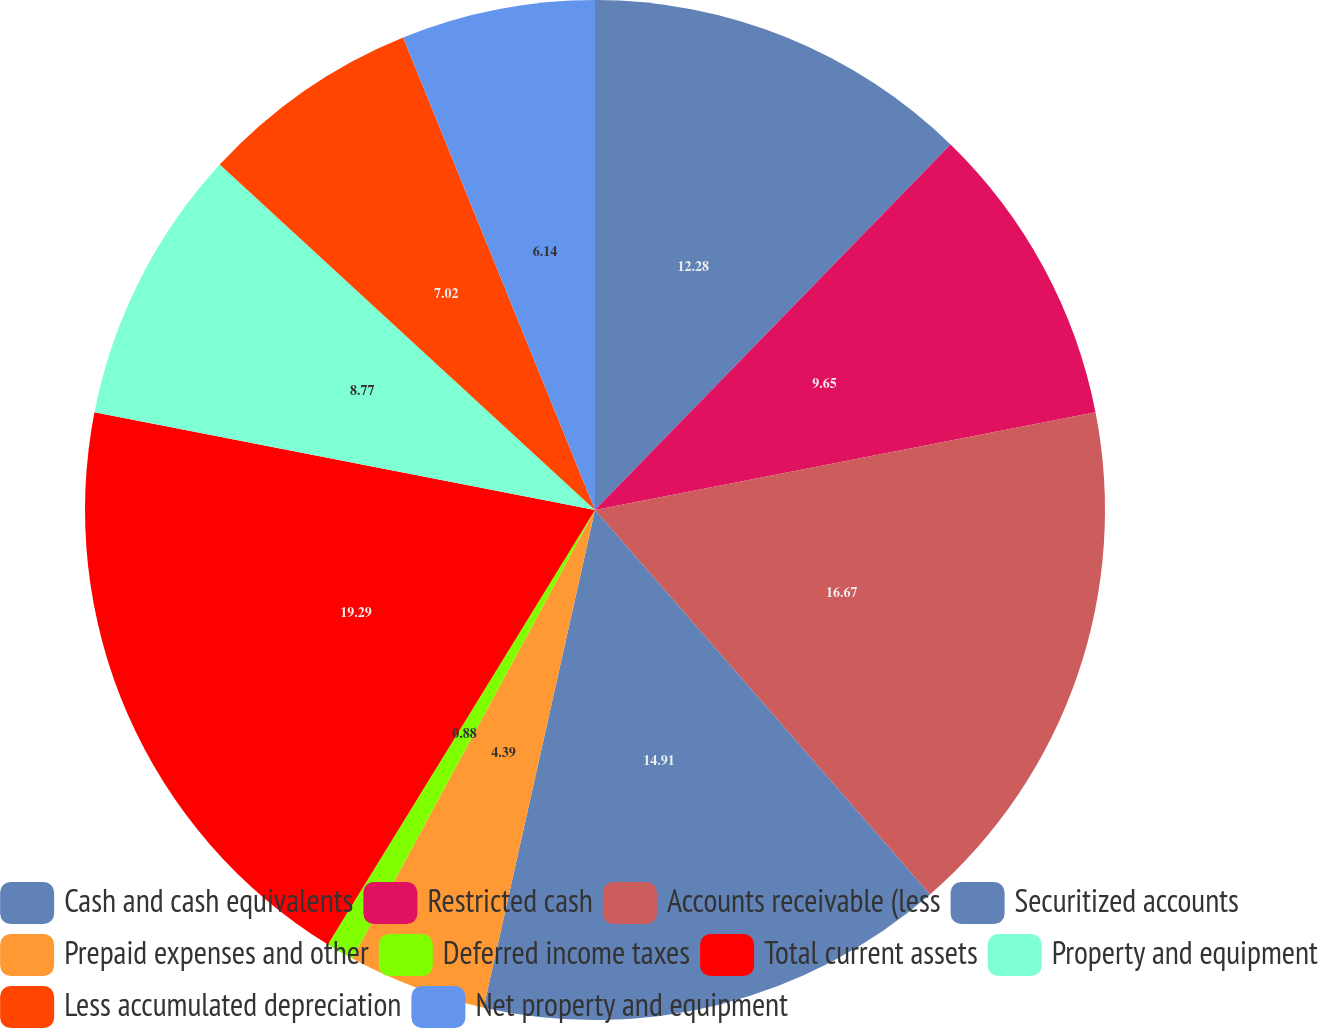Convert chart to OTSL. <chart><loc_0><loc_0><loc_500><loc_500><pie_chart><fcel>Cash and cash equivalents<fcel>Restricted cash<fcel>Accounts receivable (less<fcel>Securitized accounts<fcel>Prepaid expenses and other<fcel>Deferred income taxes<fcel>Total current assets<fcel>Property and equipment<fcel>Less accumulated depreciation<fcel>Net property and equipment<nl><fcel>12.28%<fcel>9.65%<fcel>16.67%<fcel>14.91%<fcel>4.39%<fcel>0.88%<fcel>19.3%<fcel>8.77%<fcel>7.02%<fcel>6.14%<nl></chart> 